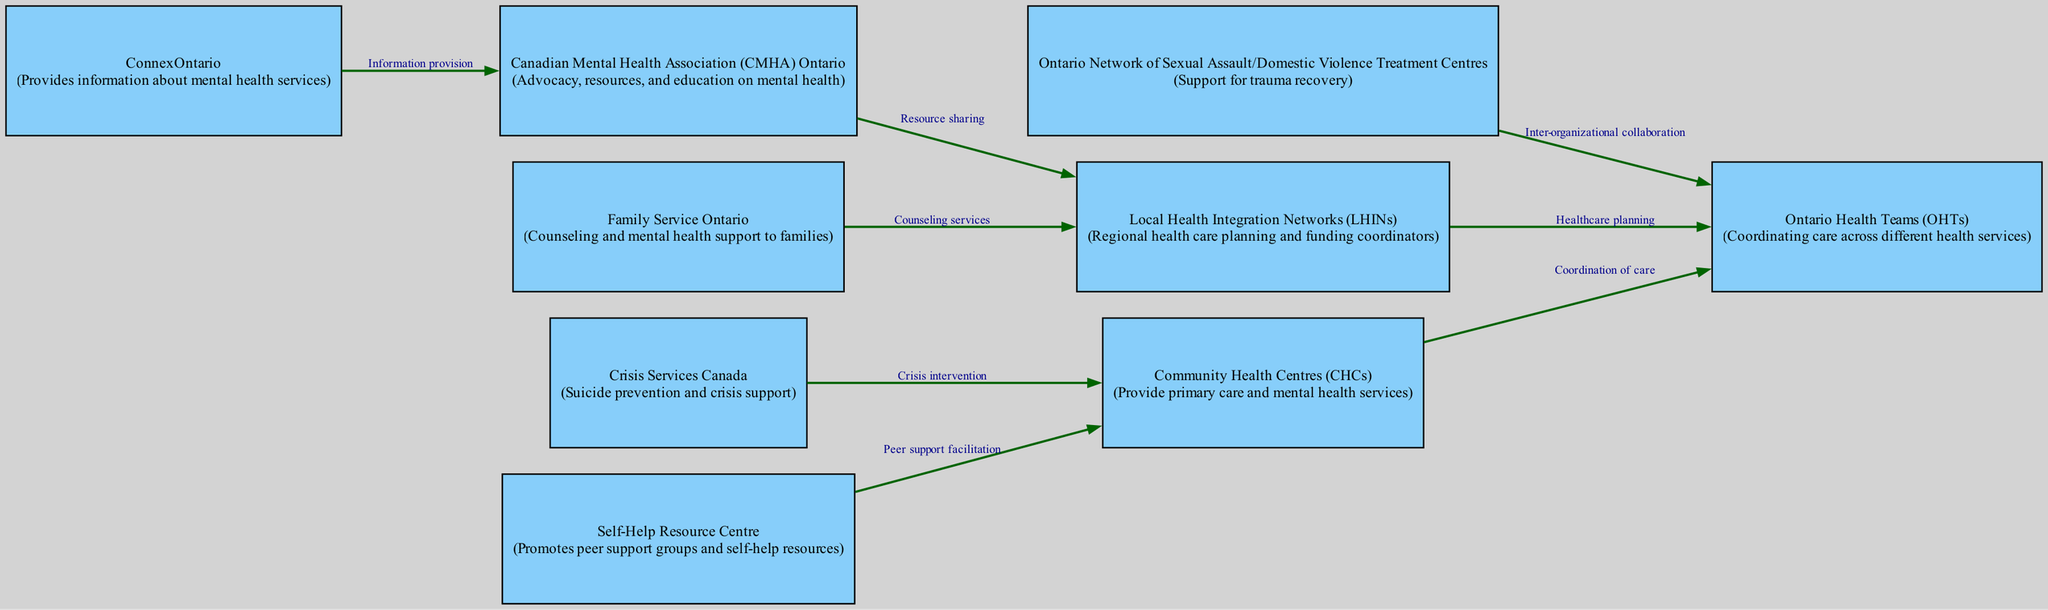What are the roles of Community Health Centres (CHCs)? Community Health Centres (CHCs) provide primary care and mental health services as indicated in the node description.
Answer: Primary care and mental health services How many organizations are depicted in the diagram? By counting the nodes listed in the diagram, we find there are nine organizations represented.
Answer: 9 Which organization provides crisis intervention? The edge leading from Crisis Services Canada to Community Health Centres indicates that Crisis Services Canada provides crisis intervention.
Answer: Crisis Services Canada What is the relationship between the Canadian Mental Health Association (CMHA) Ontario and Local Health Integration Networks (LHINs)? The edge connecting these two organizations indicates a relationship of resource sharing, as shown in the edge description.
Answer: Resource sharing What type of support do the Ontario Network of Sexual Assault/Domestic Violence Treatment Centres offer? The node description states that this organization supports trauma recovery, answering the question of their type of support.
Answer: Trauma recovery How do Family Service Ontario and Local Health Integration Networks (LHINs) connect? The edge from Family Service Ontario to Local Health Integration Networks indicates that Family Service Ontario provides counseling services that relate to the planning facilitated by LHINs.
Answer: Counseling services Which organization is responsible for coordinating care across different health services? The node for Ontario Health Teams (OHTs) describes their role in coordinating care across various health services based on the provided diagram.
Answer: Ontario Health Teams What network is tasked with regional health care planning and funding coordination? According to the node description, Local Health Integration Networks (LHINs) are responsible for healthcare planning and funding coordination.
Answer: Local Health Integration Networks What is the primary function of ConnexOntario? The node description states that ConnexOntario provides information about mental health services, identifying its primary function.
Answer: Information about mental health services 